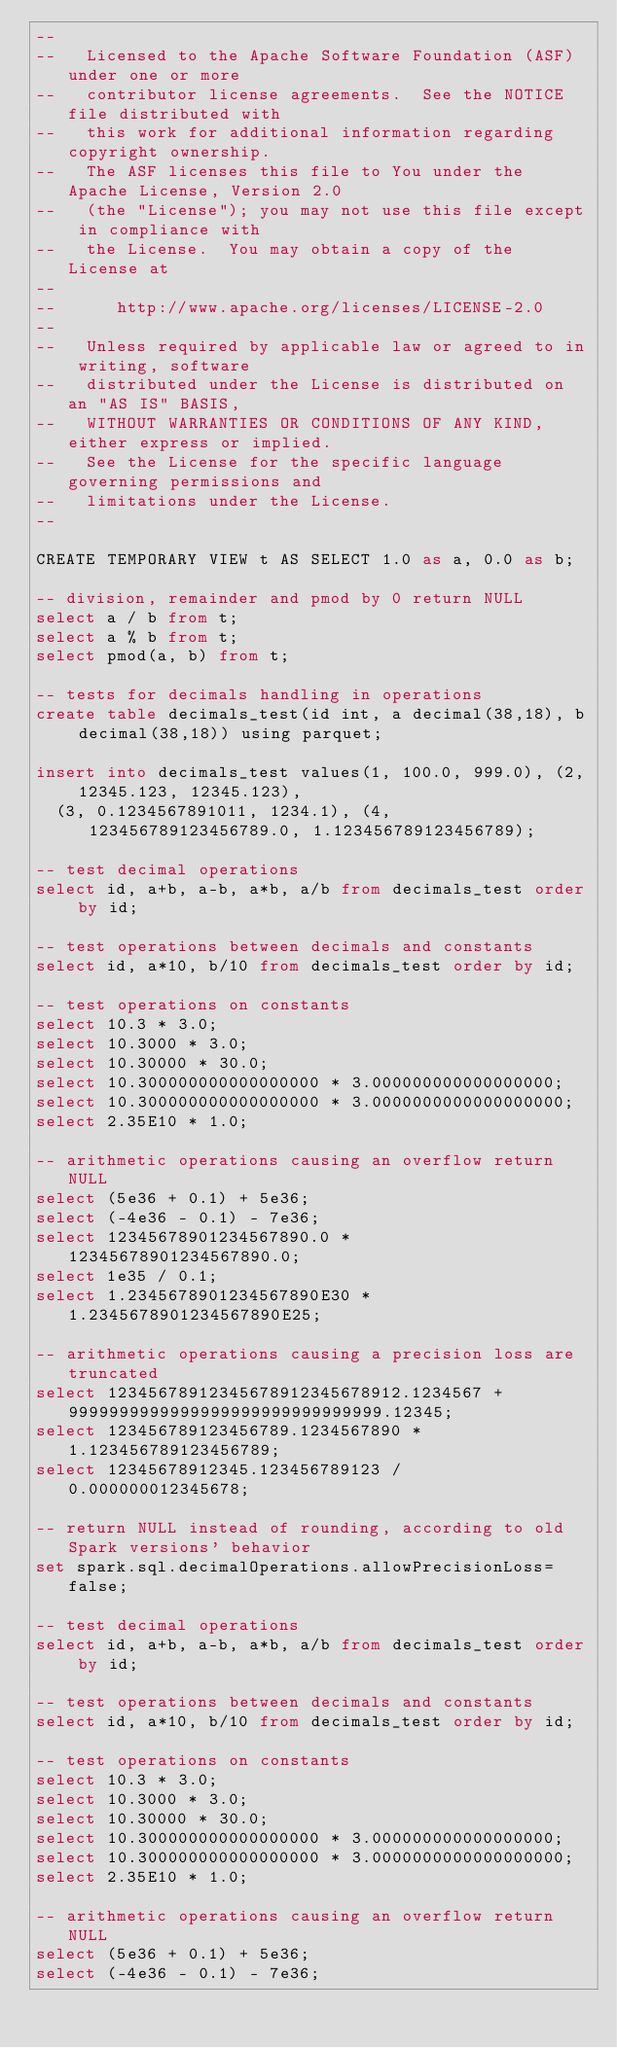Convert code to text. <code><loc_0><loc_0><loc_500><loc_500><_SQL_>--
--   Licensed to the Apache Software Foundation (ASF) under one or more
--   contributor license agreements.  See the NOTICE file distributed with
--   this work for additional information regarding copyright ownership.
--   The ASF licenses this file to You under the Apache License, Version 2.0
--   (the "License"); you may not use this file except in compliance with
--   the License.  You may obtain a copy of the License at
--
--      http://www.apache.org/licenses/LICENSE-2.0
--
--   Unless required by applicable law or agreed to in writing, software
--   distributed under the License is distributed on an "AS IS" BASIS,
--   WITHOUT WARRANTIES OR CONDITIONS OF ANY KIND, either express or implied.
--   See the License for the specific language governing permissions and
--   limitations under the License.
--

CREATE TEMPORARY VIEW t AS SELECT 1.0 as a, 0.0 as b;

-- division, remainder and pmod by 0 return NULL
select a / b from t;
select a % b from t;
select pmod(a, b) from t;

-- tests for decimals handling in operations
create table decimals_test(id int, a decimal(38,18), b decimal(38,18)) using parquet;

insert into decimals_test values(1, 100.0, 999.0), (2, 12345.123, 12345.123),
  (3, 0.1234567891011, 1234.1), (4, 123456789123456789.0, 1.123456789123456789);

-- test decimal operations
select id, a+b, a-b, a*b, a/b from decimals_test order by id;

-- test operations between decimals and constants
select id, a*10, b/10 from decimals_test order by id;

-- test operations on constants
select 10.3 * 3.0;
select 10.3000 * 3.0;
select 10.30000 * 30.0;
select 10.300000000000000000 * 3.000000000000000000;
select 10.300000000000000000 * 3.0000000000000000000;
select 2.35E10 * 1.0;

-- arithmetic operations causing an overflow return NULL
select (5e36 + 0.1) + 5e36;
select (-4e36 - 0.1) - 7e36;
select 12345678901234567890.0 * 12345678901234567890.0;
select 1e35 / 0.1;
select 1.2345678901234567890E30 * 1.2345678901234567890E25;

-- arithmetic operations causing a precision loss are truncated
select 12345678912345678912345678912.1234567 + 9999999999999999999999999999999.12345;
select 123456789123456789.1234567890 * 1.123456789123456789;
select 12345678912345.123456789123 / 0.000000012345678;

-- return NULL instead of rounding, according to old Spark versions' behavior
set spark.sql.decimalOperations.allowPrecisionLoss=false;

-- test decimal operations
select id, a+b, a-b, a*b, a/b from decimals_test order by id;

-- test operations between decimals and constants
select id, a*10, b/10 from decimals_test order by id;

-- test operations on constants
select 10.3 * 3.0;
select 10.3000 * 3.0;
select 10.30000 * 30.0;
select 10.300000000000000000 * 3.000000000000000000;
select 10.300000000000000000 * 3.0000000000000000000;
select 2.35E10 * 1.0;

-- arithmetic operations causing an overflow return NULL
select (5e36 + 0.1) + 5e36;
select (-4e36 - 0.1) - 7e36;</code> 